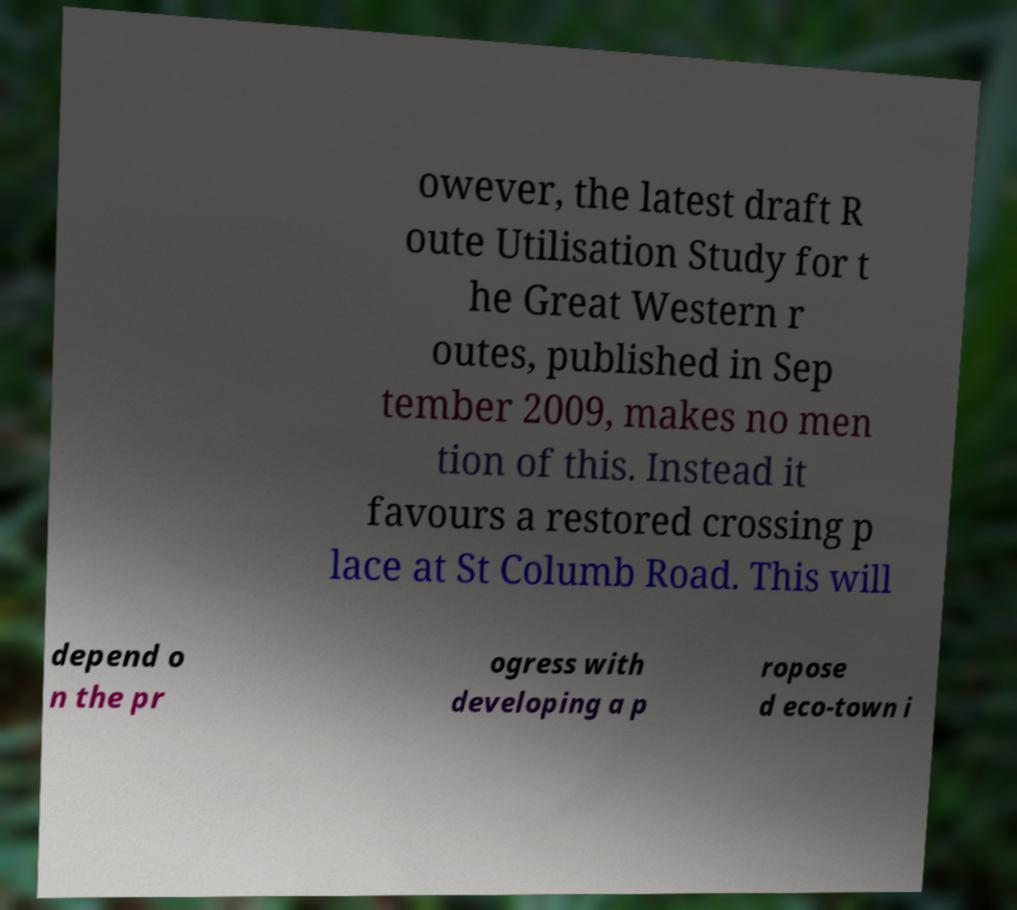Please read and relay the text visible in this image. What does it say? owever, the latest draft R oute Utilisation Study for t he Great Western r outes, published in Sep tember 2009, makes no men tion of this. Instead it favours a restored crossing p lace at St Columb Road. This will depend o n the pr ogress with developing a p ropose d eco-town i 